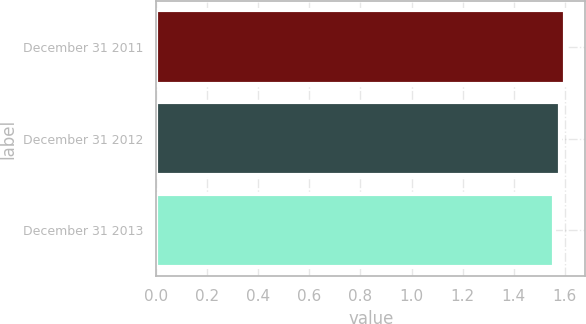Convert chart to OTSL. <chart><loc_0><loc_0><loc_500><loc_500><bar_chart><fcel>December 31 2011<fcel>December 31 2012<fcel>December 31 2013<nl><fcel>1.6<fcel>1.58<fcel>1.56<nl></chart> 